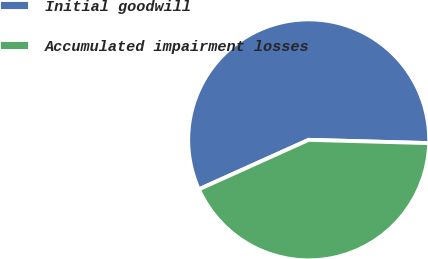Convert chart to OTSL. <chart><loc_0><loc_0><loc_500><loc_500><pie_chart><fcel>Initial goodwill<fcel>Accumulated impairment losses<nl><fcel>57.17%<fcel>42.83%<nl></chart> 